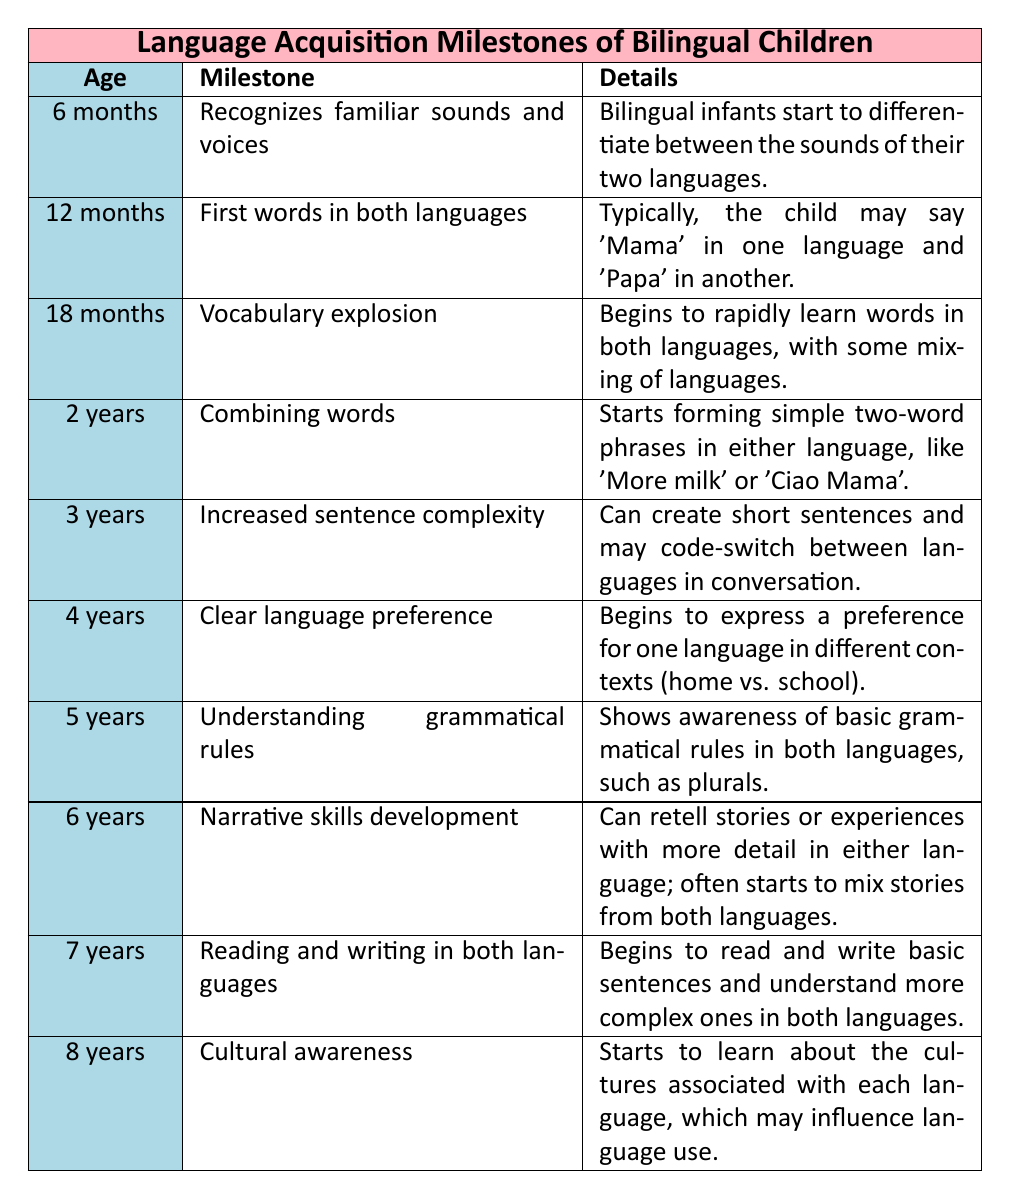What milestone occurs at 18 months? The milestone listed for 18 months is "Vocabulary explosion." This is found by locating the age in the table and reading the milestone corresponding to it.
Answer: Vocabulary explosion At what age do children begin to combine words? The table shows that children start combining words at 2 years old. This is directly stated in the row corresponding to that age.
Answer: 2 years True or false: Bilingual children recognize familiar sounds at 12 months. The table indicates that recognition of familiar sounds and voices occurs at 6 months, not at 12 months. Therefore, this statement is not true.
Answer: False What is the difference between the milestones for 4 years and 5 years? At 4 years, the milestone is "Clear language preference," while at 5 years, the milestone is "Understanding grammatical rules." The difference lies in the focus on preference vs. grammatical awareness.
Answer: Clear language preference vs. Understanding grammatical rules What age marks the beginning of narrative skills development? The narrative skills development begins at 6 years old, as stated in the corresponding row for that age in the table.
Answer: 6 years How many years after first words do children have a vocabulary explosion? First words occur at 12 months, and a vocabulary explosion occurs at 18 months. To find the difference, calculate 18 - 12 = 6 months, which equals 0.5 years.
Answer: 0.5 years True or false: Bilingual children learn to read and write in both languages by 8 years of age. According to the table, the milestone for reading and writing in both languages occurs at 7 years. Thus, the statement is true as children are beginning this process by 8 years old.
Answer: True Which age shows the first mention of cultural awareness? The milestone "Cultural awareness" appears at 8 years in the table. This is identified by checking the age column for the specific milestone.
Answer: 8 years What is the sequential order of milestones from 2 years to 4 years? The sequential order is: "Combining words" at 2 years, "Increased sentence complexity" at 3 years, and "Clear language preference" at 4 years. This is determined by reading the milestones in order from the given ages.
Answer: Combining words, Increased sentence complexity, Clear language preference 